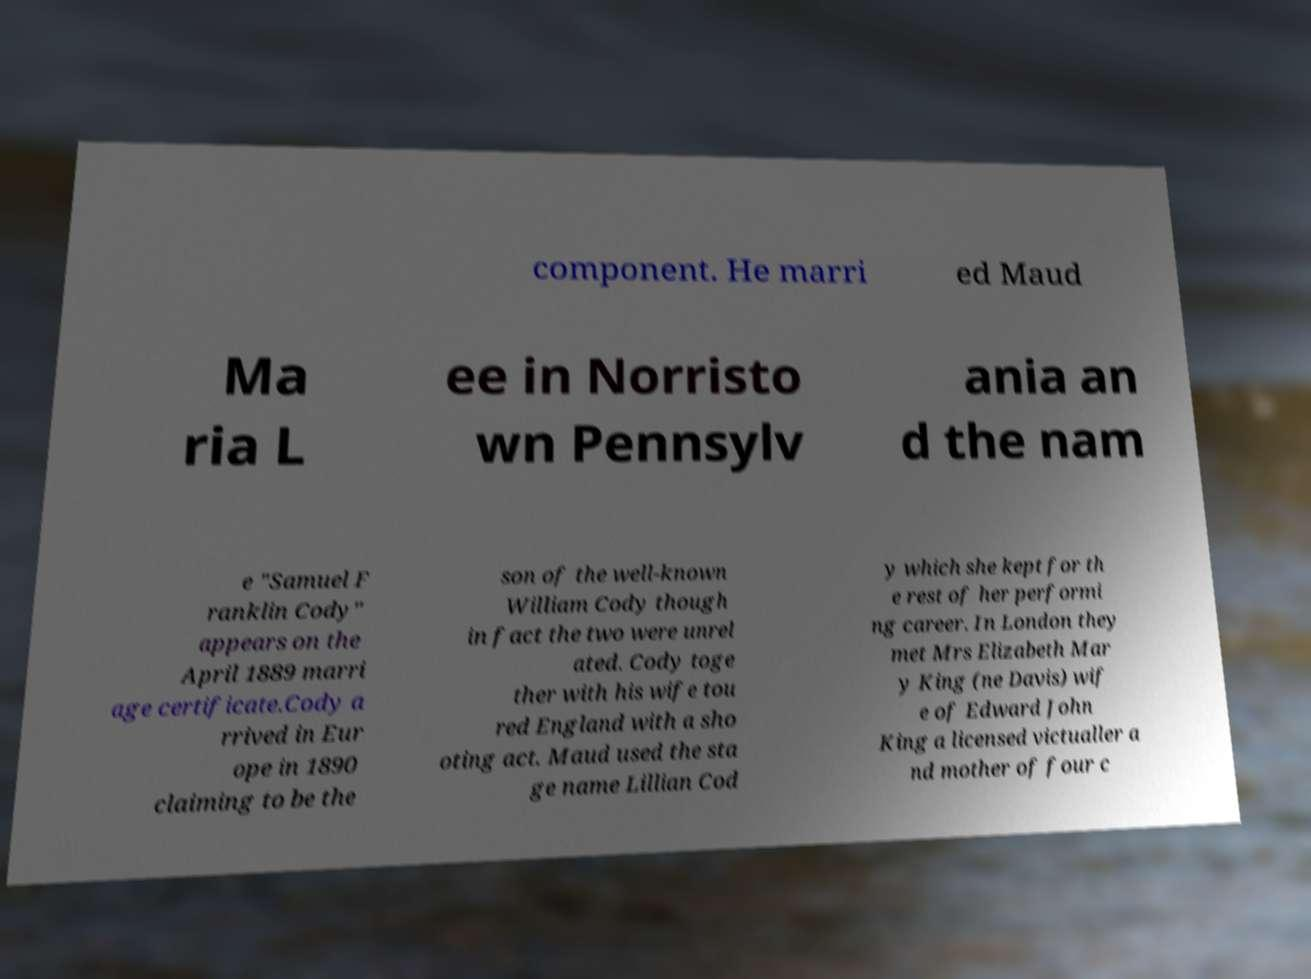Can you read and provide the text displayed in the image?This photo seems to have some interesting text. Can you extract and type it out for me? component. He marri ed Maud Ma ria L ee in Norristo wn Pennsylv ania an d the nam e "Samuel F ranklin Cody" appears on the April 1889 marri age certificate.Cody a rrived in Eur ope in 1890 claiming to be the son of the well-known William Cody though in fact the two were unrel ated. Cody toge ther with his wife tou red England with a sho oting act. Maud used the sta ge name Lillian Cod y which she kept for th e rest of her performi ng career. In London they met Mrs Elizabeth Mar y King (ne Davis) wif e of Edward John King a licensed victualler a nd mother of four c 